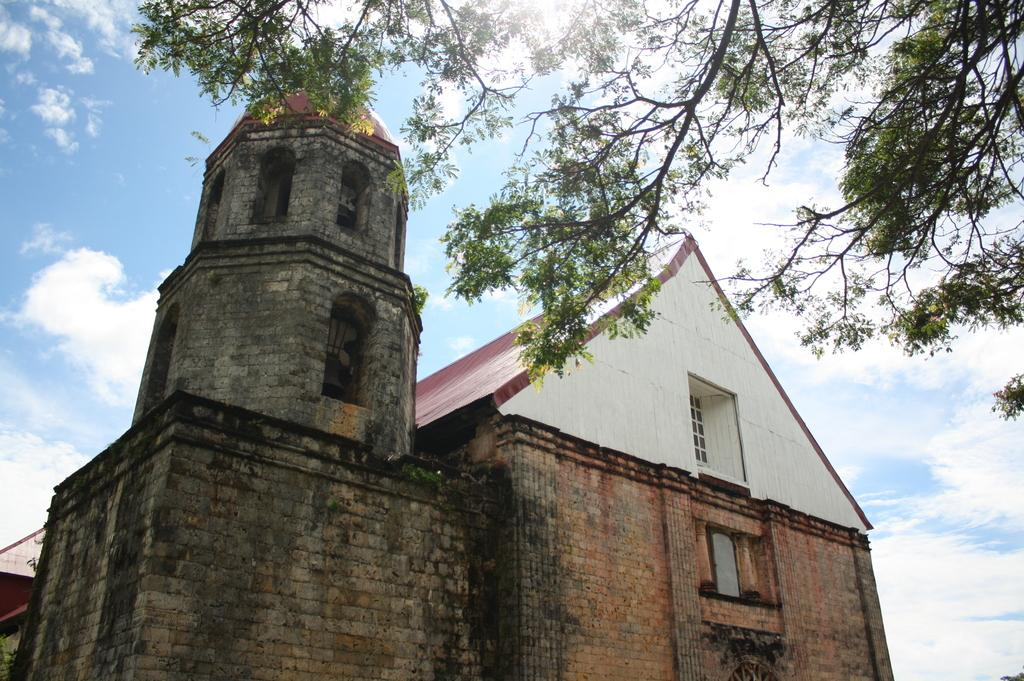What type of natural element is located on the top side of the image? There is a tree on the top side of the image. What type of man-made structure is in the front of the image? There is a building in the front of the image. What can be seen in the background of the image? There are clouds and the sky visible in the background of the image. What type of oven can be seen in the image? There is no oven present in the image. What value does the tree represent in the image? The image does not assign any specific value to the tree; it is simply a tree in the scene. 